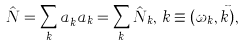<formula> <loc_0><loc_0><loc_500><loc_500>\hat { N } = \sum _ { k } a ^ { \dag } _ { k } a _ { k } = \sum _ { k } \hat { N } _ { k } , \, k \equiv ( \omega _ { k } , \vec { k } ) ,</formula> 